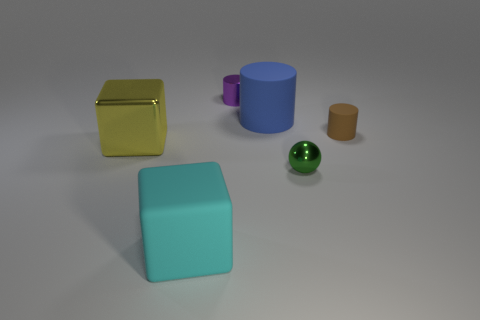How many things are either small yellow metal cylinders or tiny things?
Give a very brief answer. 3. Are the cube that is in front of the small metal sphere and the tiny thing that is to the right of the shiny sphere made of the same material?
Provide a short and direct response. Yes. The large block that is made of the same material as the big cylinder is what color?
Ensure brevity in your answer.  Cyan. What number of green matte objects have the same size as the purple cylinder?
Provide a succinct answer. 0. How many other objects are there of the same color as the tiny metallic cylinder?
Provide a short and direct response. 0. There is a tiny metal thing behind the small green shiny ball; does it have the same shape as the blue thing that is to the left of the green metal object?
Your response must be concise. Yes. What is the shape of the purple thing that is the same size as the green metallic sphere?
Keep it short and to the point. Cylinder. Is the number of small green shiny objects behind the ball the same as the number of tiny purple metal cylinders behind the yellow metallic block?
Offer a very short reply. No. Is there anything else that has the same shape as the small green shiny object?
Your answer should be very brief. No. Is the material of the large thing behind the small brown object the same as the tiny ball?
Ensure brevity in your answer.  No. 